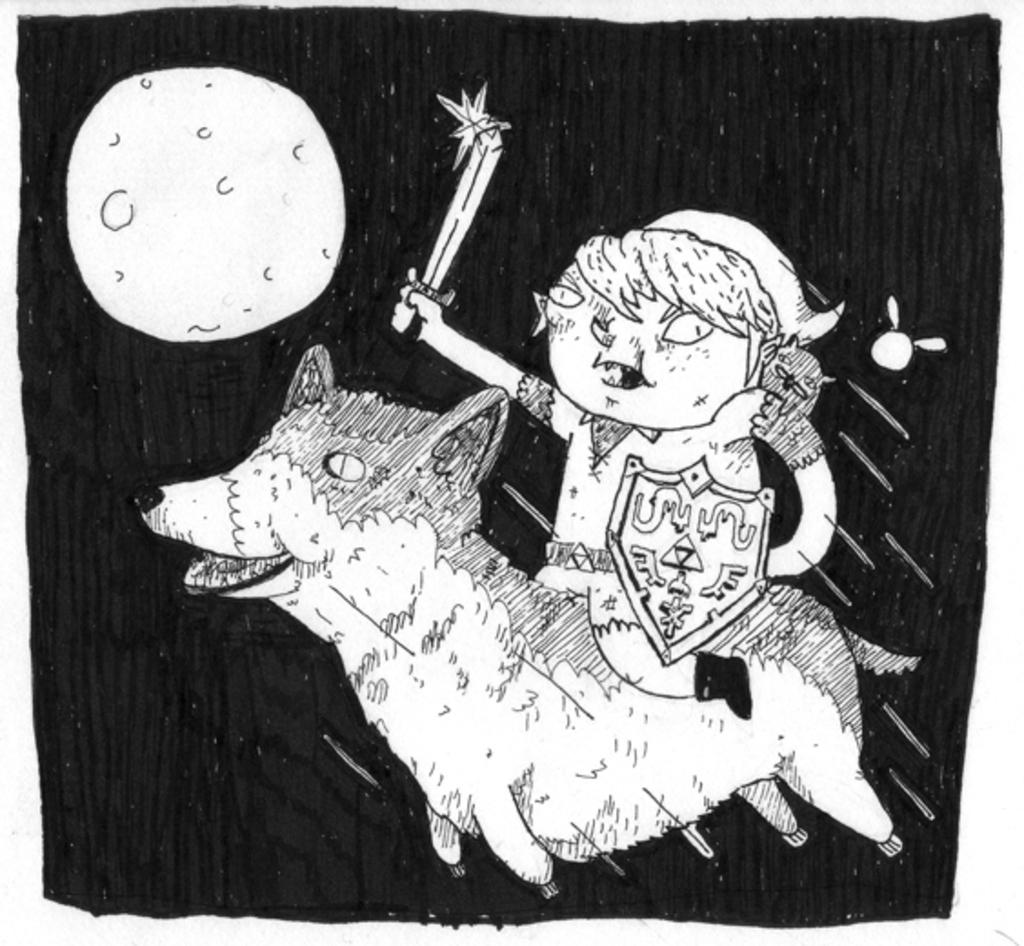Who is the main subject in the image? There is a girl in the image. What is the girl holding in the image? The girl is holding a sword. What is the girl doing in the image? The girl is riding a horse. What can be seen in the background of the image? There is a moon in the background of the image, and the background is dark. What type of artwork is this? This is a drawing. What sound does the goat make in the image? There is no goat present in the image, so it is not possible to determine the sound it might make. What is the girl's hearing like in the image? There is no information provided about the girl's hearing in the image. 